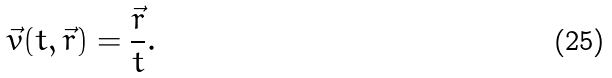Convert formula to latex. <formula><loc_0><loc_0><loc_500><loc_500>\vec { v } ( t , \vec { r } ) = \frac { \vec { r } } { t } .</formula> 